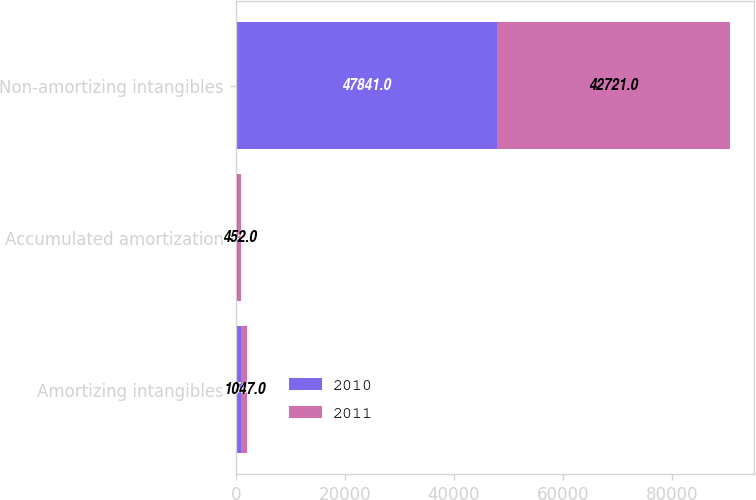Convert chart to OTSL. <chart><loc_0><loc_0><loc_500><loc_500><stacked_bar_chart><ecel><fcel>Amortizing intangibles<fcel>Accumulated amortization<fcel>Non-amortizing intangibles<nl><fcel>2010<fcel>1059<fcel>504<fcel>47841<nl><fcel>2011<fcel>1047<fcel>452<fcel>42721<nl></chart> 